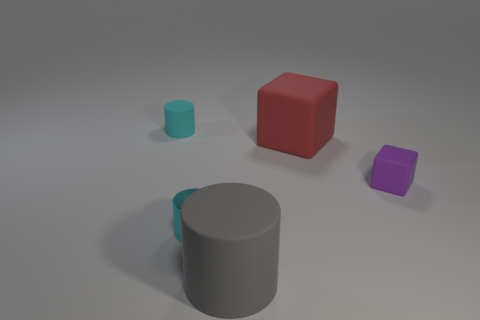Add 3 purple metallic balls. How many objects exist? 8 Subtract all cubes. How many objects are left? 3 Subtract 1 red cubes. How many objects are left? 4 Subtract all small cyan objects. Subtract all red blocks. How many objects are left? 2 Add 2 big things. How many big things are left? 4 Add 5 tiny metallic things. How many tiny metallic things exist? 6 